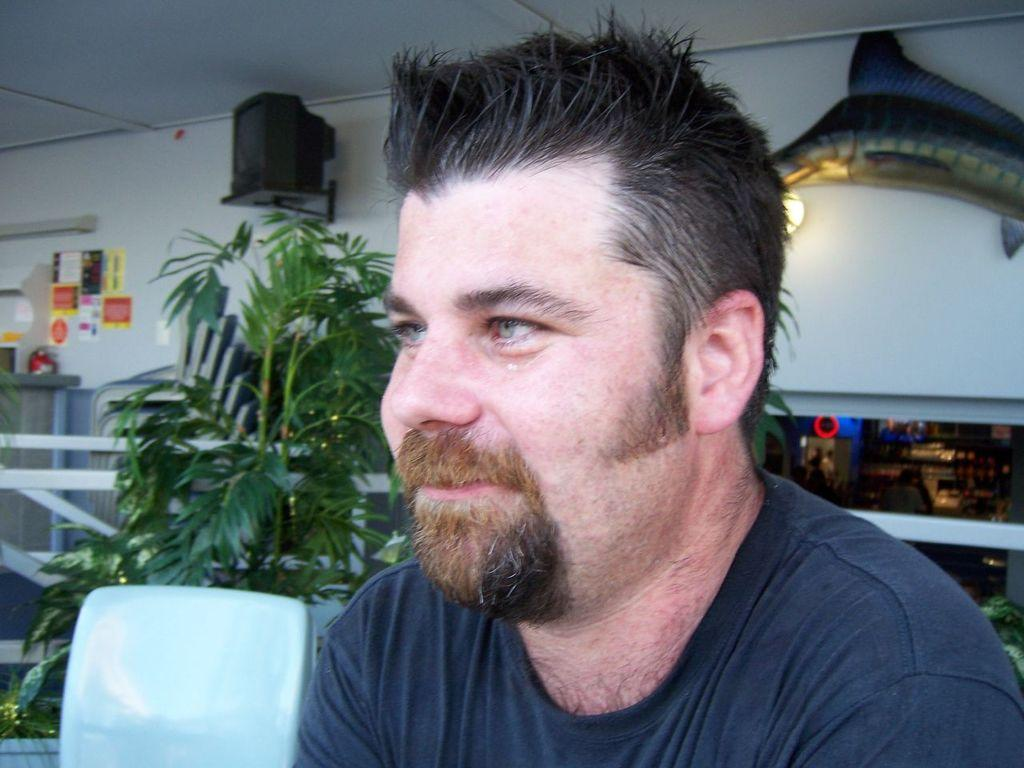Who is present in the image? There is a man in the picture. What can be seen in the background of the image? There are plants, a fence, a ceiling, lights, and objects attached to the wall in the background of the picture. What type of ray is swimming in the background of the image? There is no ray present in the image; it features a man and various background elements. What material is the iron used for in the image? There is no iron present in the image, as the background elements include a fence, ceiling, lights, and objects attached to the wall, but no iron. 